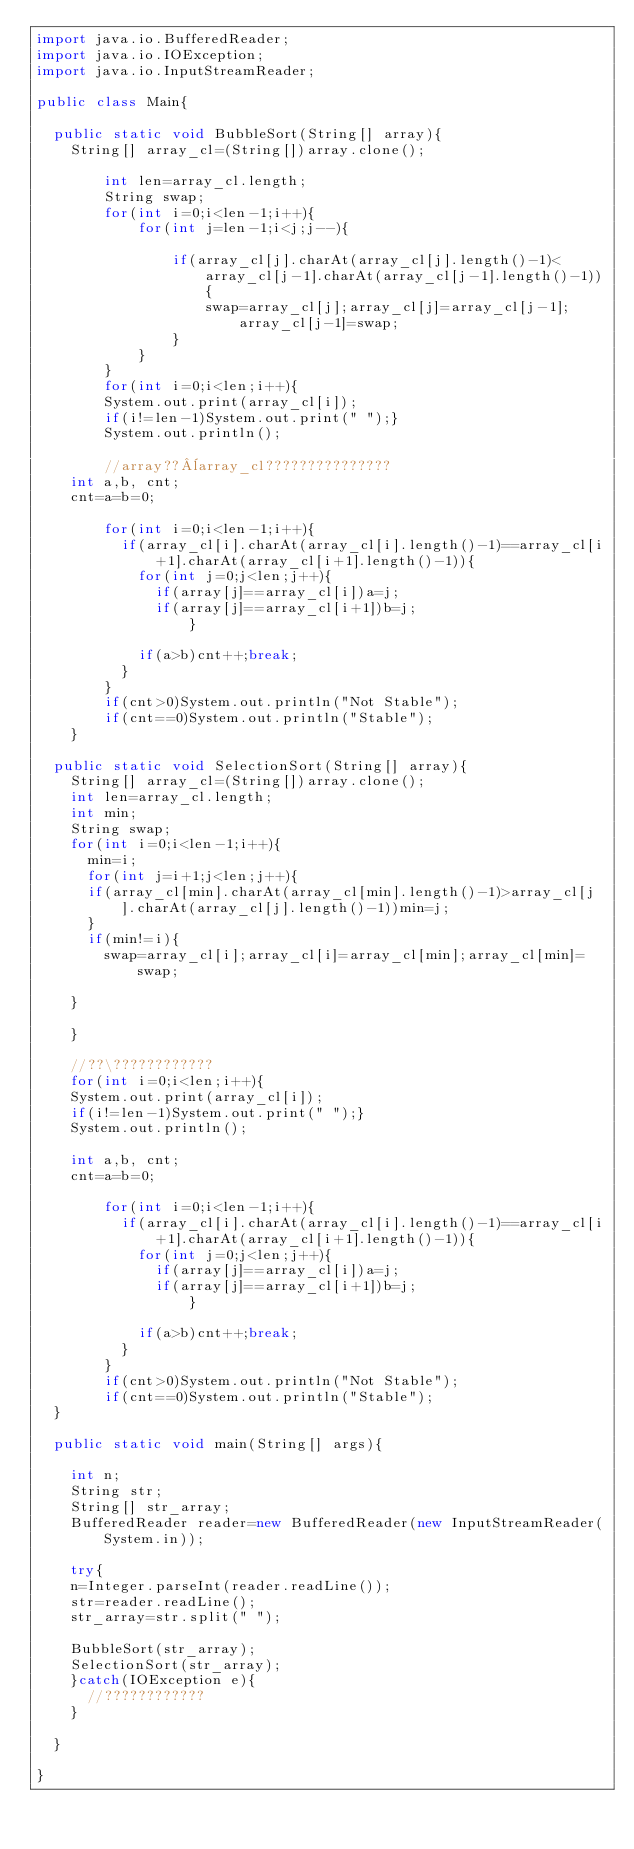Convert code to text. <code><loc_0><loc_0><loc_500><loc_500><_Java_>import java.io.BufferedReader;
import java.io.IOException;
import java.io.InputStreamReader;

public class Main{

	public static void BubbleSort(String[] array){
		String[] array_cl=(String[])array.clone();

        int len=array_cl.length;
        String swap;
        for(int i=0;i<len-1;i++){
            for(int j=len-1;i<j;j--){

                if(array_cl[j].charAt(array_cl[j].length()-1)<array_cl[j-1].charAt(array_cl[j-1].length()-1)){
                    swap=array_cl[j];array_cl[j]=array_cl[j-1];array_cl[j-1]=swap;
                }
            }
        }
        for(int i=0;i<len;i++){
        System.out.print(array_cl[i]);
        if(i!=len-1)System.out.print(" ");}
        System.out.println();

        //array??¨array_cl???????????????
		int a,b, cnt;
		cnt=a=b=0;

        for(int i=0;i<len-1;i++){
        	if(array_cl[i].charAt(array_cl[i].length()-1)==array_cl[i+1].charAt(array_cl[i+1].length()-1)){
        		for(int j=0;j<len;j++){
        			if(array[j]==array_cl[i])a=j;
        			if(array[j]==array_cl[i+1])b=j;
                	}

        		if(a>b)cnt++;break;
        	}
        }
        if(cnt>0)System.out.println("Not Stable");
        if(cnt==0)System.out.println("Stable");
    }

	public static void SelectionSort(String[] array){
		String[] array_cl=(String[])array.clone();
		int len=array_cl.length;
		int min;
		String swap;
		for(int i=0;i<len-1;i++){
			min=i;
			for(int j=i+1;j<len;j++){
			if(array_cl[min].charAt(array_cl[min].length()-1)>array_cl[j].charAt(array_cl[j].length()-1))min=j;
			}
			if(min!=i){
				swap=array_cl[i];array_cl[i]=array_cl[min];array_cl[min]=swap;

		}

		}

		//??\????????????
		for(int i=0;i<len;i++){
		System.out.print(array_cl[i]);
		if(i!=len-1)System.out.print(" ");}
		System.out.println();

		int a,b, cnt;
		cnt=a=b=0;

        for(int i=0;i<len-1;i++){
        	if(array_cl[i].charAt(array_cl[i].length()-1)==array_cl[i+1].charAt(array_cl[i+1].length()-1)){
        		for(int j=0;j<len;j++){
        			if(array[j]==array_cl[i])a=j;
        			if(array[j]==array_cl[i+1])b=j;
                	}

        		if(a>b)cnt++;break;
        	}
        }
        if(cnt>0)System.out.println("Not Stable");
        if(cnt==0)System.out.println("Stable");
	}

	public static void main(String[] args){

		int n;
		String str;
		String[] str_array;
		BufferedReader reader=new BufferedReader(new InputStreamReader(System.in));

		try{
		n=Integer.parseInt(reader.readLine());
		str=reader.readLine();
		str_array=str.split(" ");

		BubbleSort(str_array);
		SelectionSort(str_array);
		}catch(IOException e){
			//????????????
		}

	}

}</code> 